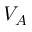<formula> <loc_0><loc_0><loc_500><loc_500>V _ { A }</formula> 